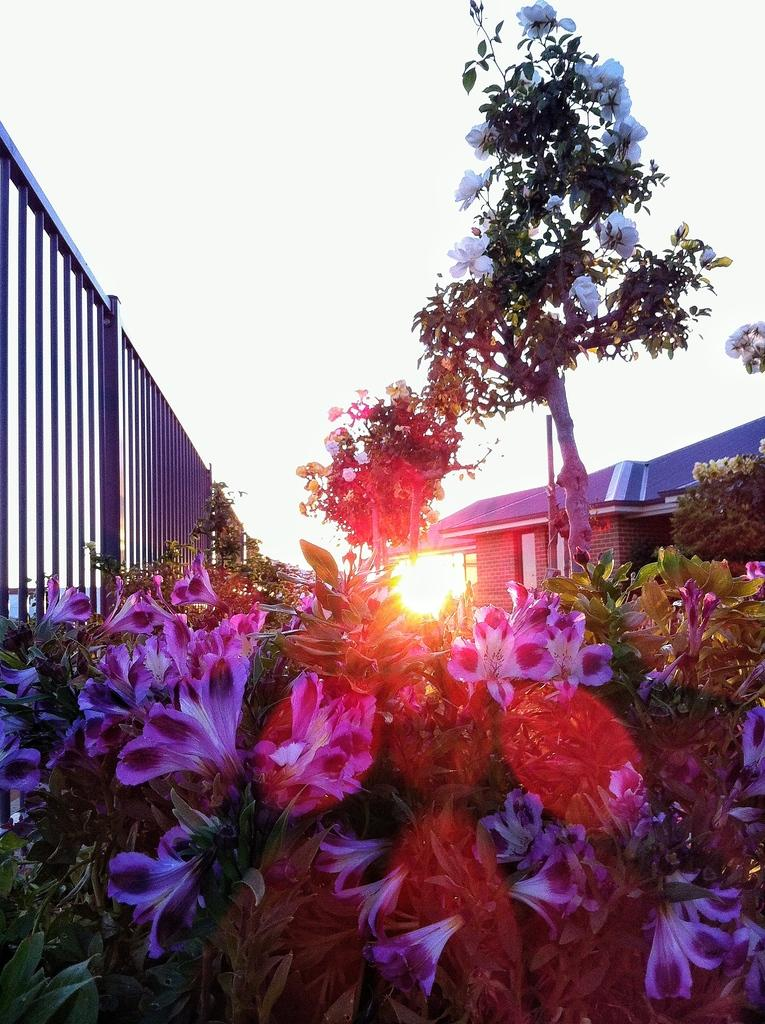What type of vegetation can be seen in the image? There are flowers, plants, and a tree in the image. What type of structure is present in the image? There is a lighthouse in the image. What is the purpose of the fence in the image? The fence in the image serves as a boundary or barrier. What can be seen in the sky in the image? The sky is visible in the image. How many times does the person in the image sneeze? There is no person present in the image, so it is not possible to determine how many times they sneeze. What type of town can be seen in the image? There is no town present in the image; it features a lighthouse, vegetation, and a fence. 